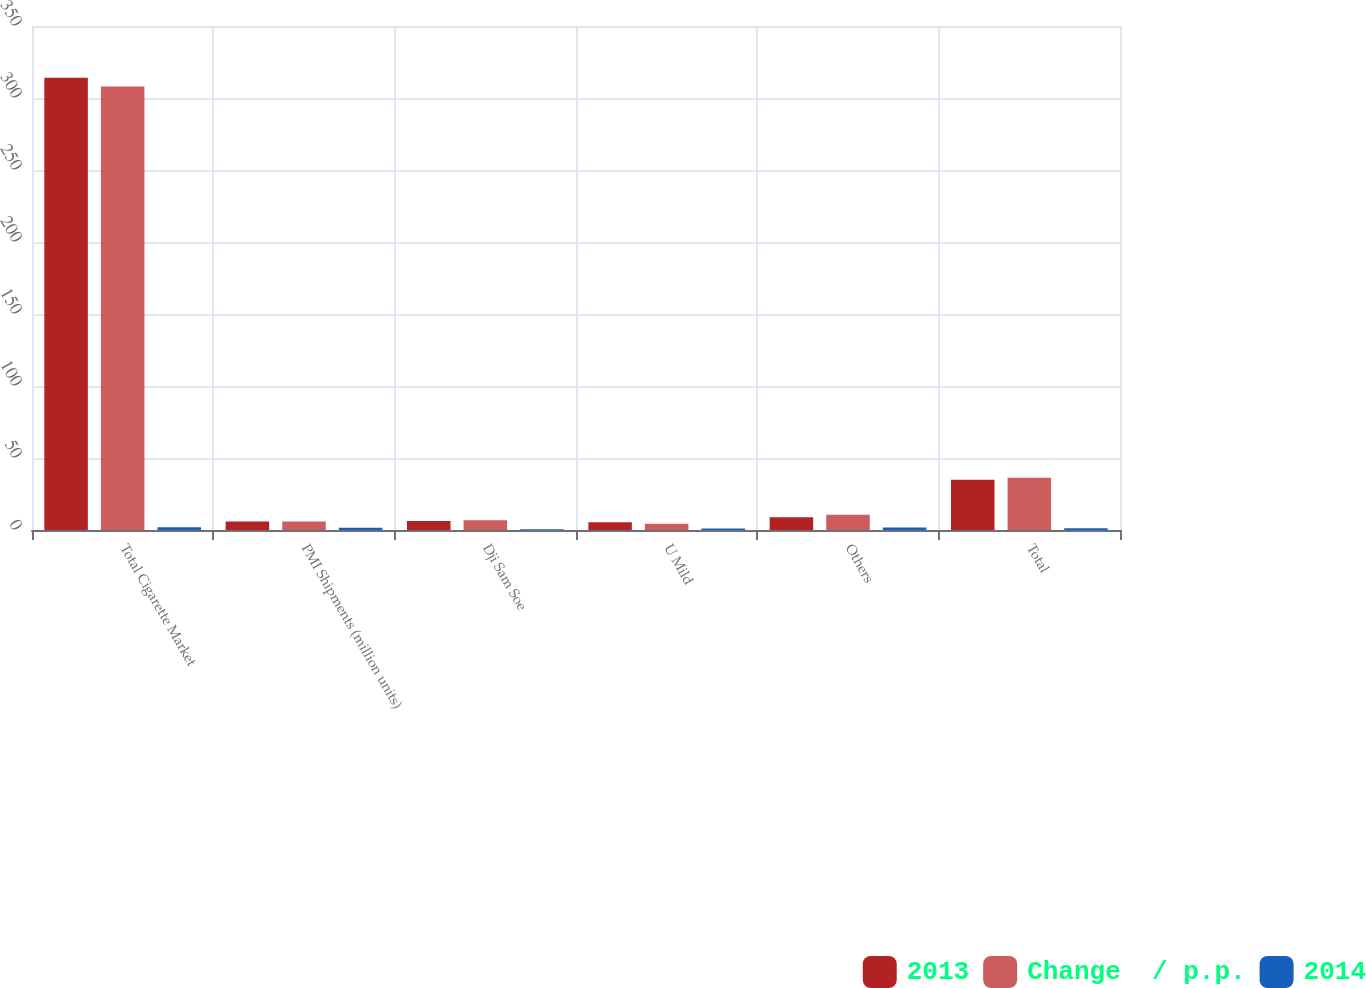Convert chart to OTSL. <chart><loc_0><loc_0><loc_500><loc_500><stacked_bar_chart><ecel><fcel>Total Cigarette Market<fcel>PMI Shipments (million units)<fcel>Dji Sam Soe<fcel>U Mild<fcel>Others<fcel>Total<nl><fcel>2013<fcel>314<fcel>5.85<fcel>6.3<fcel>5.4<fcel>8.8<fcel>34.9<nl><fcel>Change  / p.p.<fcel>308<fcel>5.85<fcel>6.8<fcel>4.4<fcel>10.6<fcel>36.2<nl><fcel>2014<fcel>1.9<fcel>1.5<fcel>0.5<fcel>1<fcel>1.8<fcel>1.3<nl></chart> 